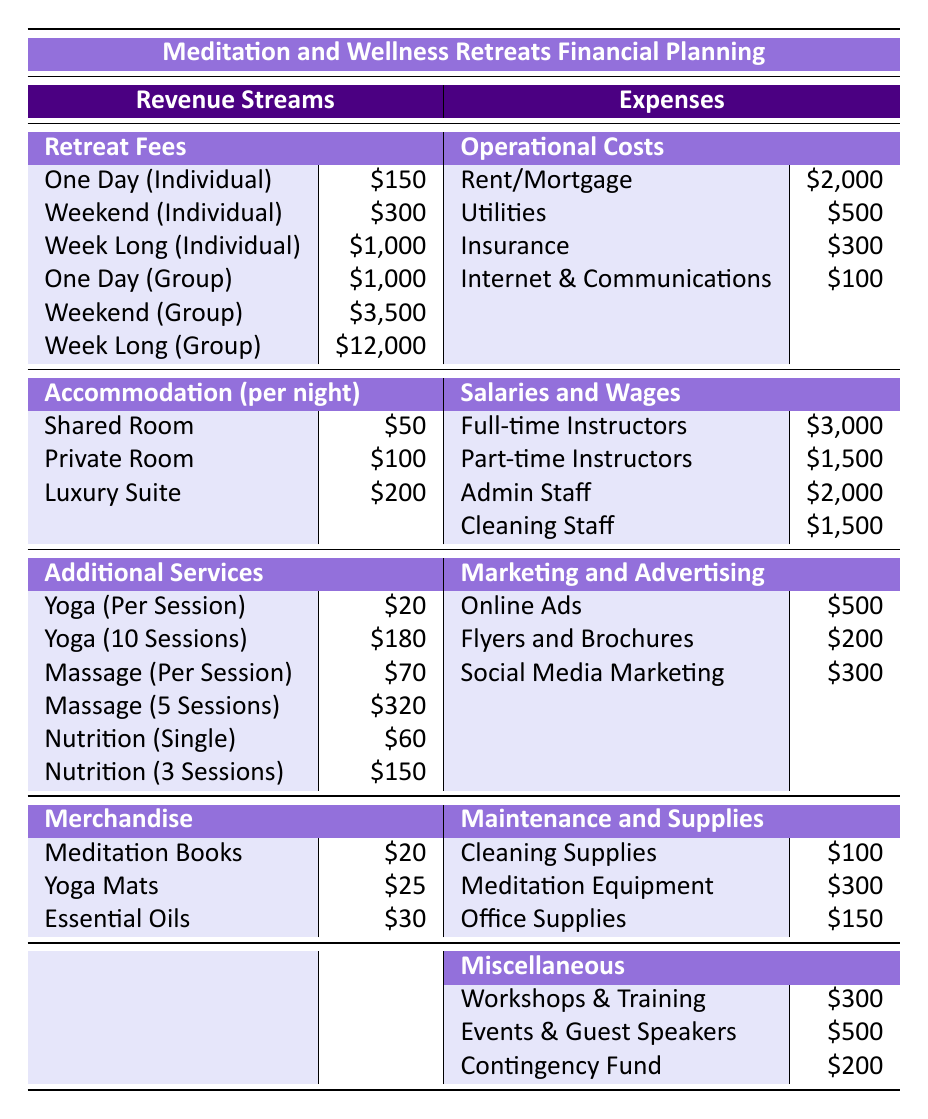What is the cost of a one-day individual retreat session? The table lists the price for a one-day individual session under Retreat Fees as 150.
Answer: 150 What are the total marketing and advertising expenses? To find the total marketing and advertising expenses, we sum the costs: 500 (online ads) + 200 (flyers and brochures) + 300 (social media marketing) = 1000.
Answer: 1000 Is the weekly cost for a luxury suite more than for a shared room? Since a luxury suite costs 200, and a shared room costs 50, 200 is greater than 50. Therefore, the statement is true.
Answer: Yes What is the difference in cost between a weekend group session and a week-long group session? The cost for a weekend group session is 3500, and for a week-long group session, it is 12000. The difference is calculated as 12000 - 3500 = 8500.
Answer: 8500 What are the total expenses for instructors and admin staff? To calculate total expenses: full-time instructors cost 3000, part-time instructors cost 1500, admin staff costs 2000. Therefore, the total is 3000 + 1500 + 2000 = 6500.
Answer: 6500 What is the total revenue from weekend individual sessions? The revenue from weekend individual sessions is listed as 300. Since there's only one value for this category, it is already the total.
Answer: 300 Are the total operational costs higher than the total miscellaneous expenses? The total operational costs sum up as follows: 2000 (rent) + 500 (utilities) + 300 (insurance) + 100 (internet) = 2900. Total miscellaneous expenses are 300 (workshops) + 500 (events) + 200 (contingency) = 1000. Since 2900 > 1000, the statement is true.
Answer: Yes How much would it cost for a package of 10 yoga sessions? The cost for a package of 10 yoga sessions, as per Additional Services, is priced at 180.
Answer: 180 What is the total lodging cost for three nights in a private room? The cost of a private room is 100 per night. For three nights, it amounts to 100 x 3 = 300.
Answer: 300 